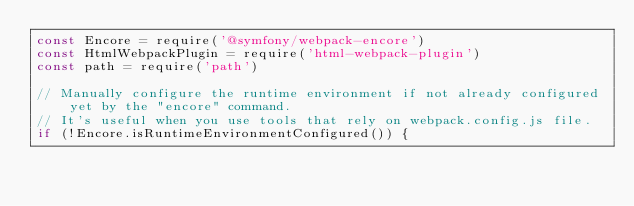Convert code to text. <code><loc_0><loc_0><loc_500><loc_500><_JavaScript_>const Encore = require('@symfony/webpack-encore')
const HtmlWebpackPlugin = require('html-webpack-plugin')
const path = require('path')

// Manually configure the runtime environment if not already configured yet by the "encore" command.
// It's useful when you use tools that rely on webpack.config.js file.
if (!Encore.isRuntimeEnvironmentConfigured()) {</code> 